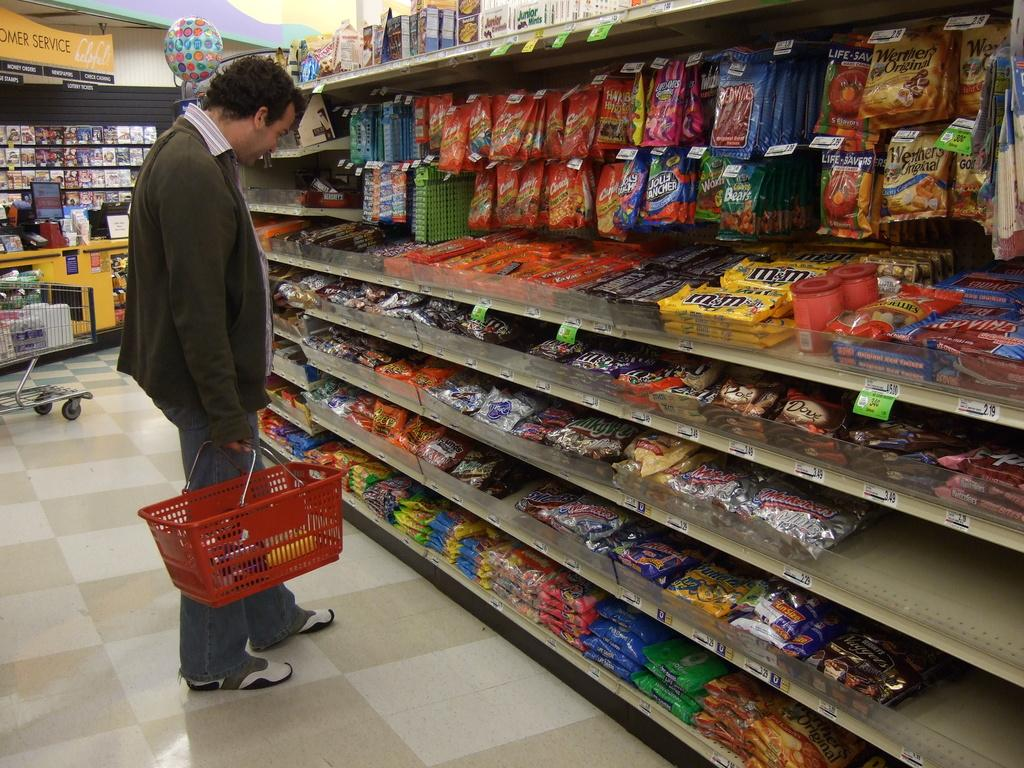<image>
Render a clear and concise summary of the photo. a store aisle full of candys with one of them being 'hershey's' 